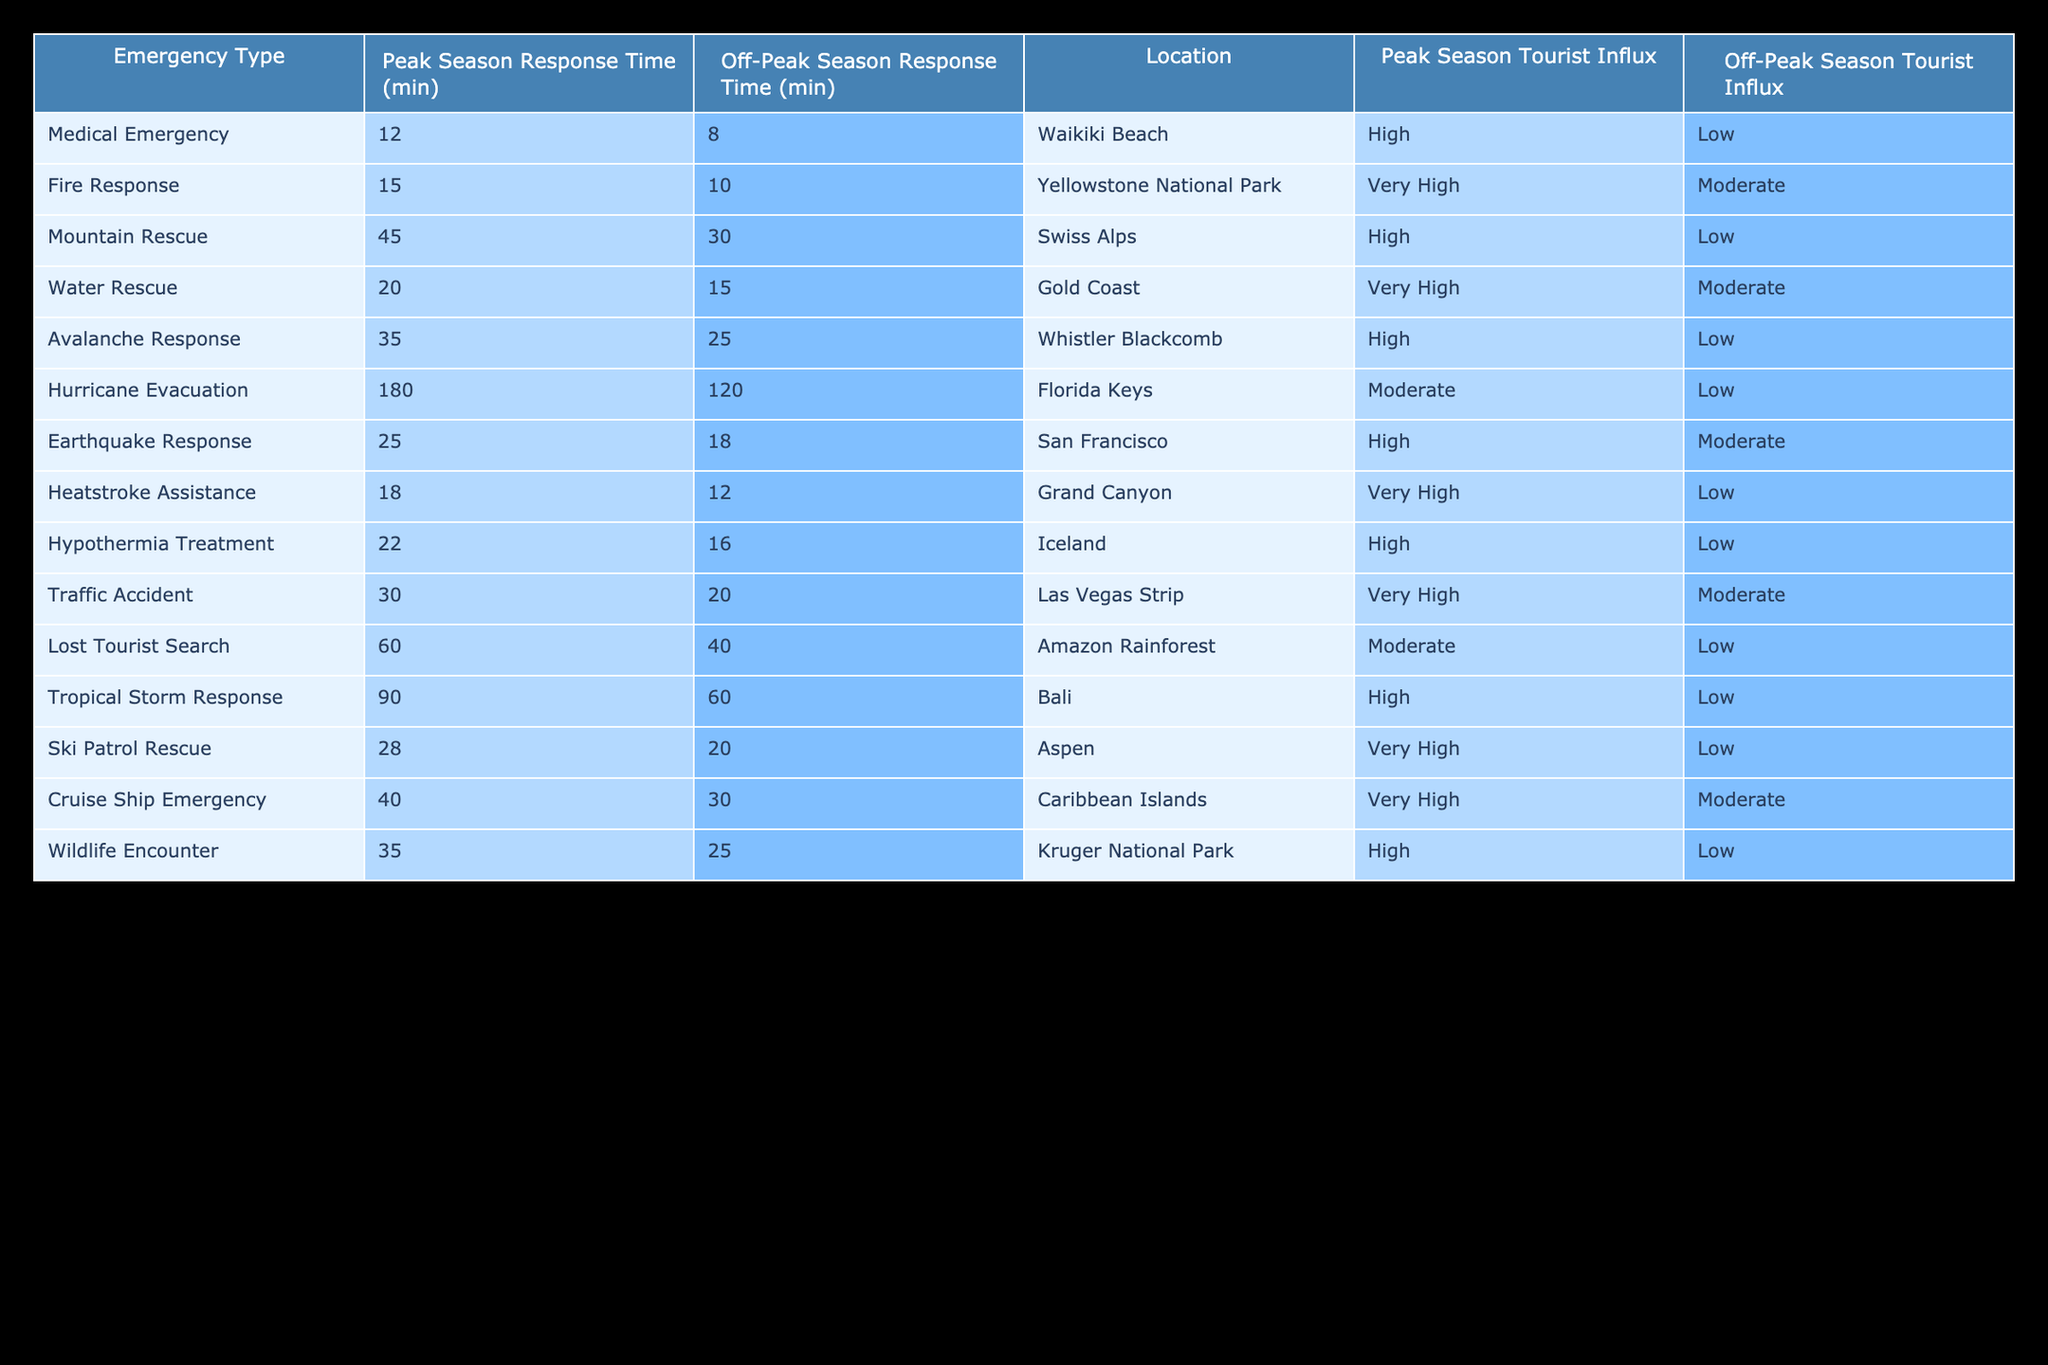What is the peak season response time for medical emergencies at Waikiki Beach? The table indicates that the peak season response time for medical emergencies at Waikiki Beach is 12 minutes.
Answer: 12 minutes How much longer does it take to respond to fire emergencies during the peak season compared to the off-peak season in Yellowstone National Park? The peak season response time for fire emergencies is 15 minutes and the off-peak time is 10 minutes. The difference is 15 - 10 = 5 minutes.
Answer: 5 minutes Is the response time for mountain rescues shorter during the off-peak season in the Swiss Alps? The table shows a peak season response time of 45 minutes and off-peak time of 30 minutes, indicating that the off-peak season response time is shorter.
Answer: Yes Which emergency type has the highest peak season response time, and what is that time? The highest peak season response time listed in the table is 180 minutes for hurricane evacuation in the Florida Keys.
Answer: Hurricane evacuation, 180 minutes What is the average response time for water rescues in both peak and off-peak seasons at Gold Coast? The peak season response time for water rescues is 20 minutes and off-peak is 15 minutes. The average is (20 + 15) / 2 = 17.5 minutes.
Answer: 17.5 minutes During which season is the response time for heatstroke assistance longer, and by how much? The peak season response time for heatstroke assistance is 18 minutes, while the off-peak season is 12 minutes. Thus, the peak season is longer by 18 - 12 = 6 minutes.
Answer: Peak season, 6 minutes How many minutes does the response time for lost tourist searches decrease from peak to off-peak season in the Amazon Rainforest? The peak season response time is 60 minutes and the off-peak time is 40 minutes. The decrease is 60 - 40 = 20 minutes.
Answer: 20 minutes Are hurricane evacuation response times shorter than avalanche response times during the peak season? The peak season response time for hurricane evacuation is 180 minutes while the response time for avalanche response is 35 minutes. 180 minutes is longer than 35 minutes, thus hurricane evacuation times are not shorter.
Answer: No What is the difference between the off-peak response times for traffic accidents and hypothermia treatment? The off-peak response time for traffic accidents is 20 minutes, while for hypothermia treatment it is 16 minutes. The difference is 20 - 16 = 4 minutes.
Answer: 4 minutes 